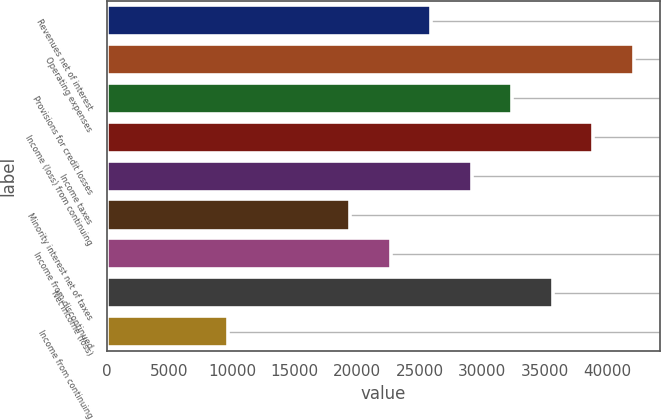<chart> <loc_0><loc_0><loc_500><loc_500><bar_chart><fcel>Revenues net of interest<fcel>Operating expenses<fcel>Provisions for credit losses<fcel>Income (loss) from continuing<fcel>Income taxes<fcel>Minority interest net of taxes<fcel>Income from discontinued<fcel>Net income (loss)<fcel>Income from continuing<nl><fcel>25912<fcel>42106.9<fcel>32390<fcel>38867.9<fcel>29151<fcel>19434<fcel>22673<fcel>35628.9<fcel>9717.1<nl></chart> 